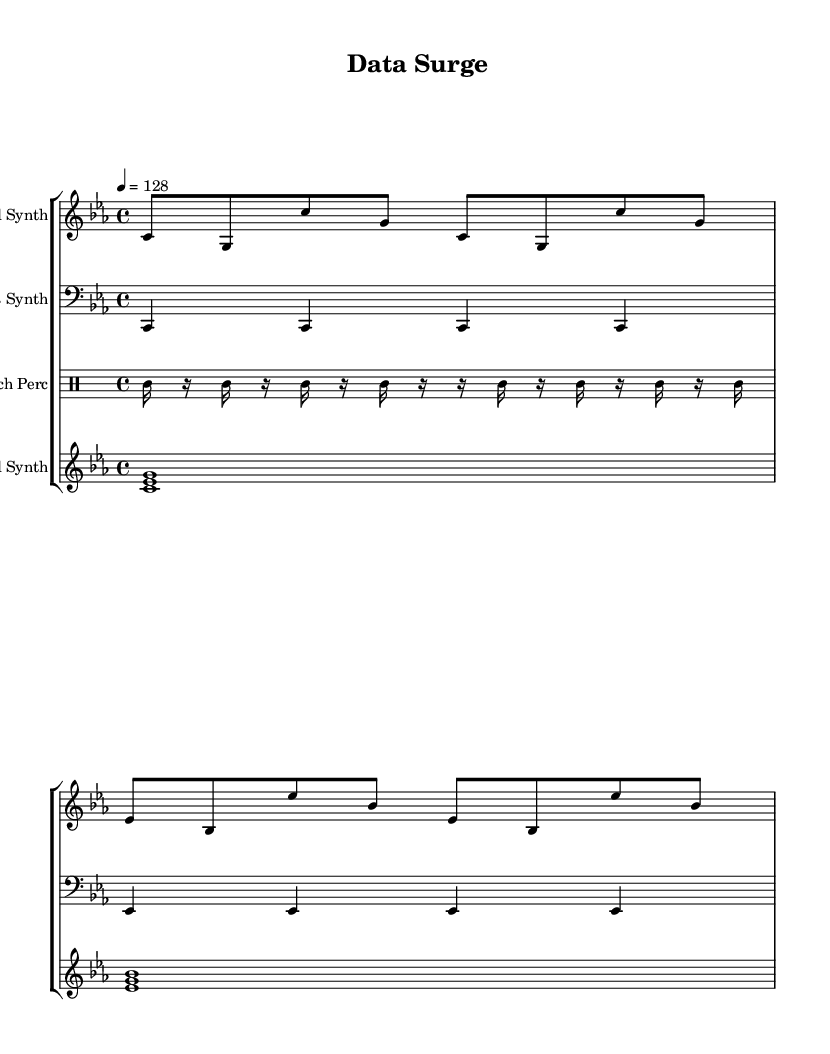What is the key signature of this music? The key signature is C minor, which has three flats: B♭, E♭, and A♭. This can be determined from the clef and the lack of any accidentals throughout the piece.
Answer: C minor What is the time signature of this music? The time signature is 4/4, which appears at the beginning of the score next to the clef. This means there are four beats per measure.
Answer: 4/4 What is the tempo marking of this piece? The tempo marking indicates the piece should be played at a speed of 128 beats per minute, as shown in the tempo directive.
Answer: 128 How many measures are in the lead synth part? The lead synth part consists of two measures, which can be counted by looking at the notation and visible bar lines in the music.
Answer: 2 What rhythmic value does the glitch percussion primarily use? The glitch percussion primarily uses sixteenth notes, as shown by the frequent appearance of the sixteenth note symbol throughout its score.
Answer: Sixteenth notes Which two instruments are playing notes simultaneously in the first measure? In the first measure, the lead synth and bass synth are the two instruments playing simultaneous notes, as indicated by their respective staves containing notes at the same time.
Answer: Lead synth, bass synth What type of synthesis is indicated by the pad synth chords? The pad synth includes sustained chords, characteristic of pad synthesis often used in electronic music for atmospheric soundscapes, indicated by the tied notes.
Answer: Pad synthesis 